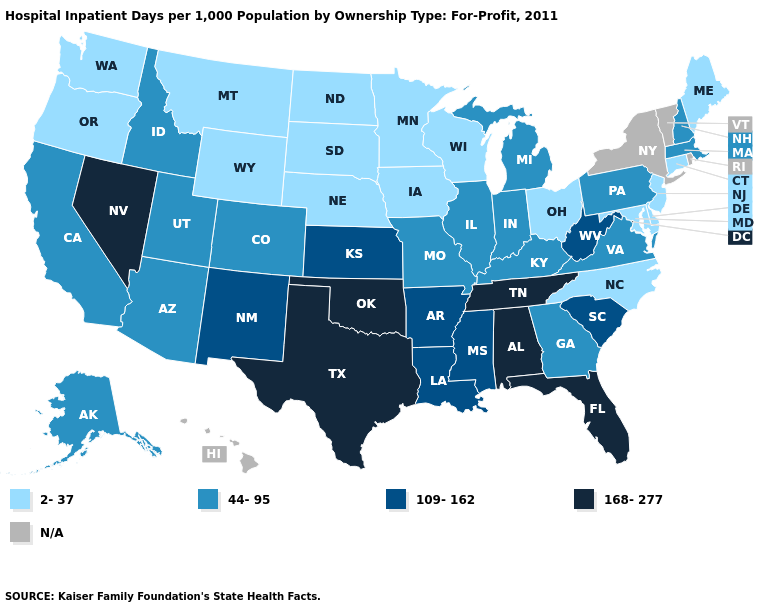Does South Carolina have the lowest value in the USA?
Quick response, please. No. Name the states that have a value in the range N/A?
Keep it brief. Hawaii, New York, Rhode Island, Vermont. Name the states that have a value in the range 44-95?
Quick response, please. Alaska, Arizona, California, Colorado, Georgia, Idaho, Illinois, Indiana, Kentucky, Massachusetts, Michigan, Missouri, New Hampshire, Pennsylvania, Utah, Virginia. Name the states that have a value in the range 2-37?
Write a very short answer. Connecticut, Delaware, Iowa, Maine, Maryland, Minnesota, Montana, Nebraska, New Jersey, North Carolina, North Dakota, Ohio, Oregon, South Dakota, Washington, Wisconsin, Wyoming. Which states have the lowest value in the USA?
Concise answer only. Connecticut, Delaware, Iowa, Maine, Maryland, Minnesota, Montana, Nebraska, New Jersey, North Carolina, North Dakota, Ohio, Oregon, South Dakota, Washington, Wisconsin, Wyoming. Which states have the lowest value in the USA?
Short answer required. Connecticut, Delaware, Iowa, Maine, Maryland, Minnesota, Montana, Nebraska, New Jersey, North Carolina, North Dakota, Ohio, Oregon, South Dakota, Washington, Wisconsin, Wyoming. What is the value of Oregon?
Write a very short answer. 2-37. What is the lowest value in the USA?
Be succinct. 2-37. Does the first symbol in the legend represent the smallest category?
Concise answer only. Yes. Name the states that have a value in the range 44-95?
Short answer required. Alaska, Arizona, California, Colorado, Georgia, Idaho, Illinois, Indiana, Kentucky, Massachusetts, Michigan, Missouri, New Hampshire, Pennsylvania, Utah, Virginia. Name the states that have a value in the range 168-277?
Short answer required. Alabama, Florida, Nevada, Oklahoma, Tennessee, Texas. What is the lowest value in states that border Mississippi?
Keep it brief. 109-162. 